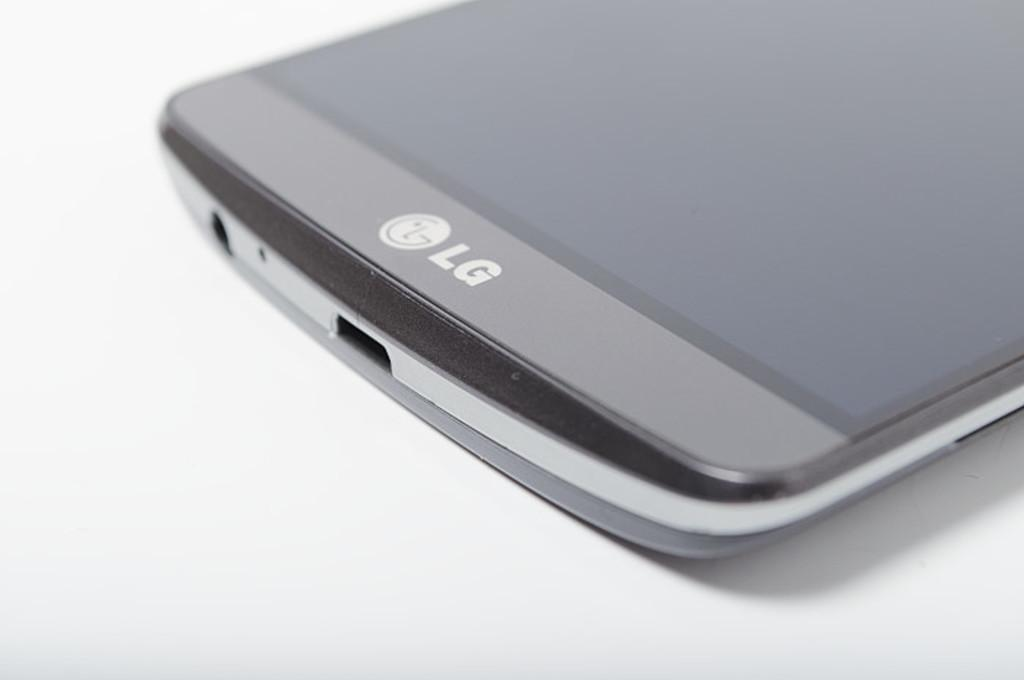<image>
Share a concise interpretation of the image provided. The grey mobile device shown on a white screen is made by LG. 